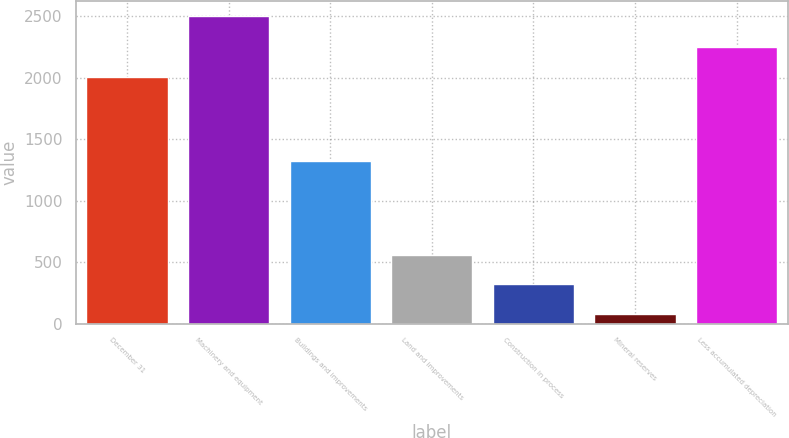Convert chart to OTSL. <chart><loc_0><loc_0><loc_500><loc_500><bar_chart><fcel>December 31<fcel>Machinery and equipment<fcel>Buildings and improvements<fcel>Land and improvements<fcel>Construction in process<fcel>Mineral reserves<fcel>Less accumulated depreciation<nl><fcel>2004<fcel>2500<fcel>1320<fcel>562.4<fcel>320.2<fcel>78<fcel>2246.2<nl></chart> 